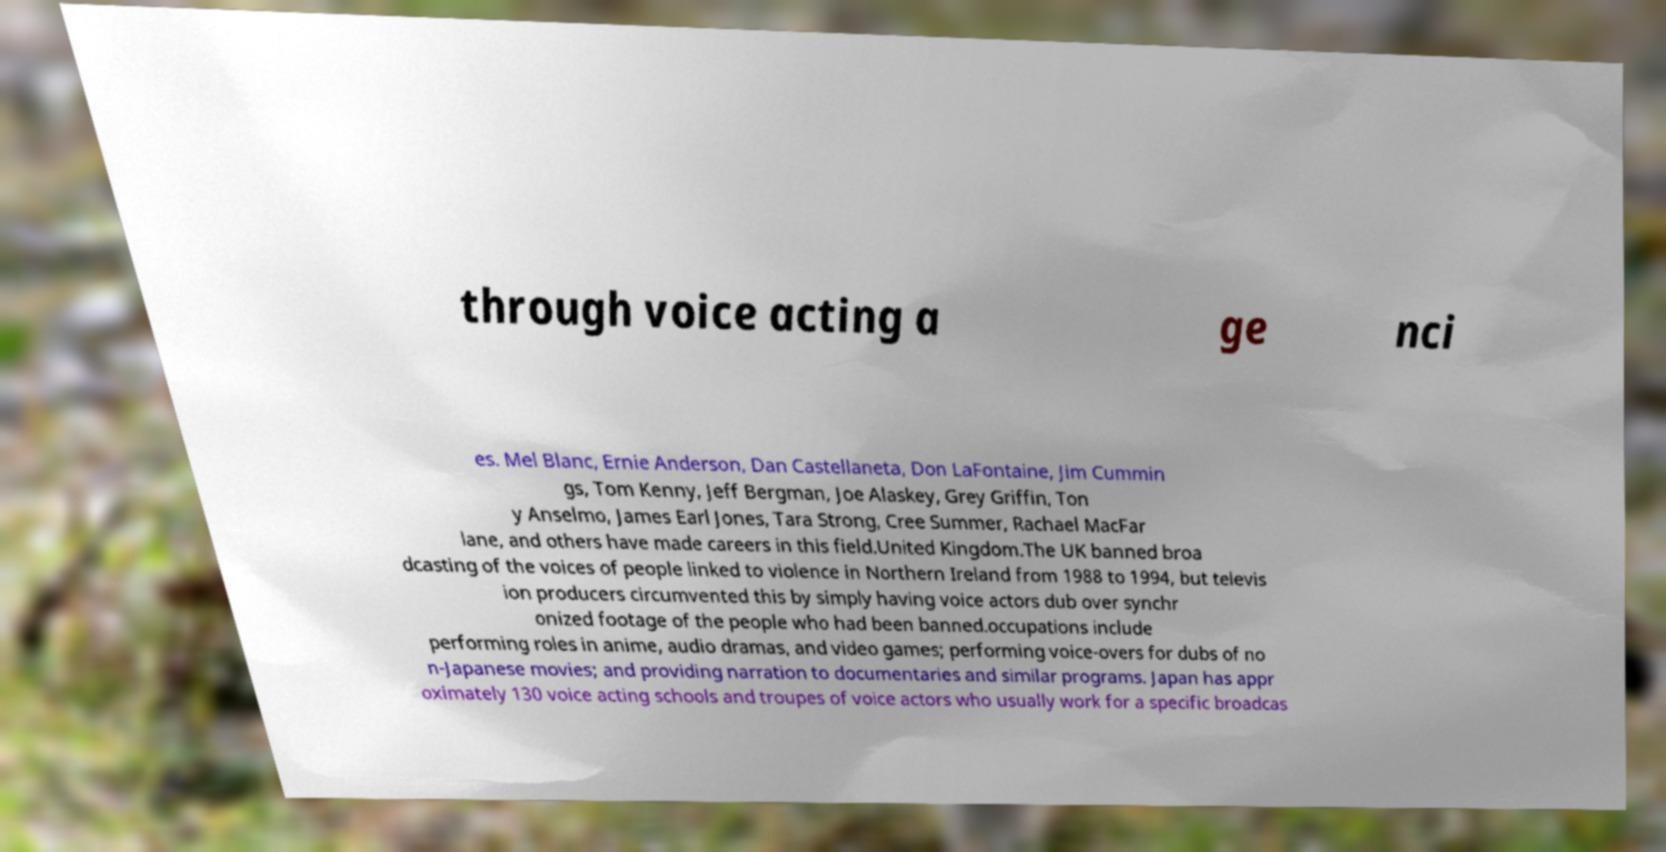There's text embedded in this image that I need extracted. Can you transcribe it verbatim? through voice acting a ge nci es. Mel Blanc, Ernie Anderson, Dan Castellaneta, Don LaFontaine, Jim Cummin gs, Tom Kenny, Jeff Bergman, Joe Alaskey, Grey Griffin, Ton y Anselmo, James Earl Jones, Tara Strong, Cree Summer, Rachael MacFar lane, and others have made careers in this field.United Kingdom.The UK banned broa dcasting of the voices of people linked to violence in Northern Ireland from 1988 to 1994, but televis ion producers circumvented this by simply having voice actors dub over synchr onized footage of the people who had been banned.occupations include performing roles in anime, audio dramas, and video games; performing voice-overs for dubs of no n-Japanese movies; and providing narration to documentaries and similar programs. Japan has appr oximately 130 voice acting schools and troupes of voice actors who usually work for a specific broadcas 